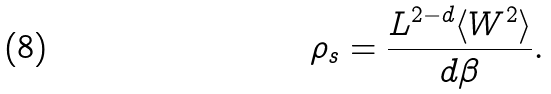Convert formula to latex. <formula><loc_0><loc_0><loc_500><loc_500>\rho _ { s } = \frac { L ^ { 2 - d } \langle W ^ { 2 } \rangle } { d \beta } .</formula> 